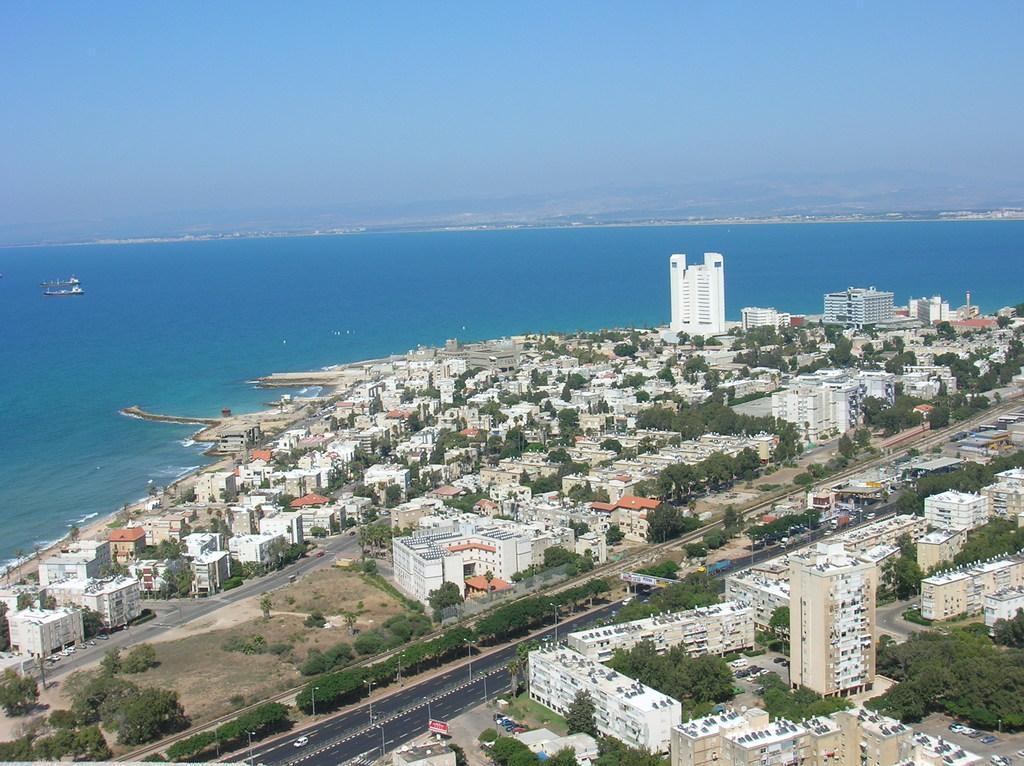In one or two sentences, can you explain what this image depicts? In this image on the foreground there are buildings,trees, roads, vehicles. In the background on a water body there are ships. The sky is clear. 